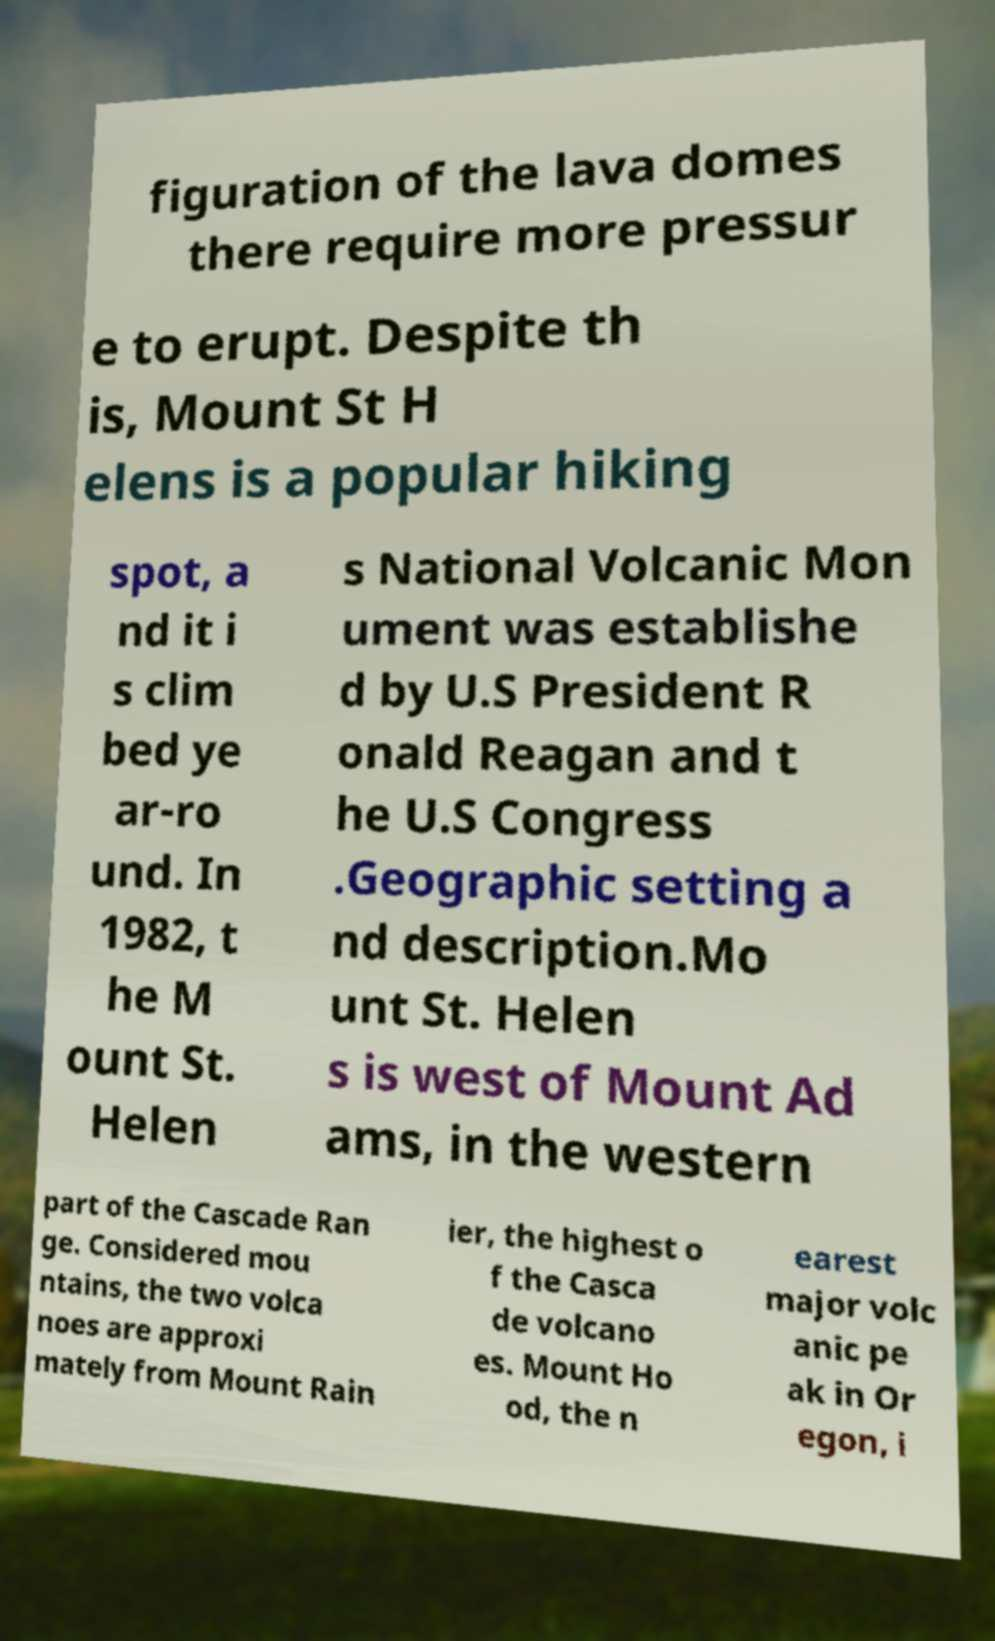Could you assist in decoding the text presented in this image and type it out clearly? figuration of the lava domes there require more pressur e to erupt. Despite th is, Mount St H elens is a popular hiking spot, a nd it i s clim bed ye ar-ro und. In 1982, t he M ount St. Helen s National Volcanic Mon ument was establishe d by U.S President R onald Reagan and t he U.S Congress .Geographic setting a nd description.Mo unt St. Helen s is west of Mount Ad ams, in the western part of the Cascade Ran ge. Considered mou ntains, the two volca noes are approxi mately from Mount Rain ier, the highest o f the Casca de volcano es. Mount Ho od, the n earest major volc anic pe ak in Or egon, i 